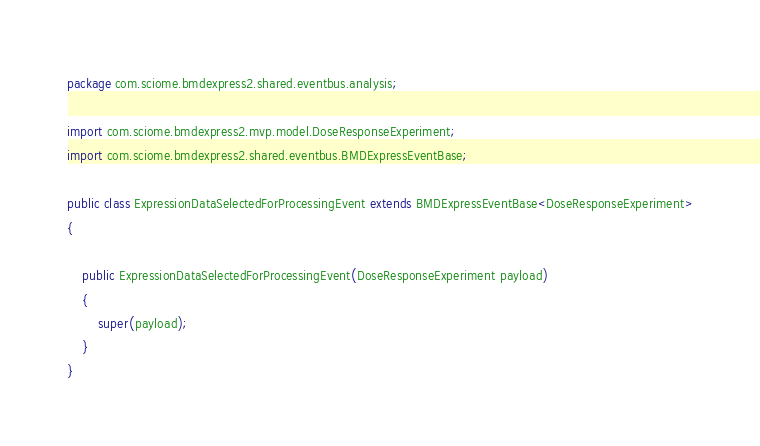<code> <loc_0><loc_0><loc_500><loc_500><_Java_>package com.sciome.bmdexpress2.shared.eventbus.analysis;

import com.sciome.bmdexpress2.mvp.model.DoseResponseExperiment;
import com.sciome.bmdexpress2.shared.eventbus.BMDExpressEventBase;

public class ExpressionDataSelectedForProcessingEvent extends BMDExpressEventBase<DoseResponseExperiment>
{

	public ExpressionDataSelectedForProcessingEvent(DoseResponseExperiment payload)
	{
		super(payload);
	}
}
</code> 